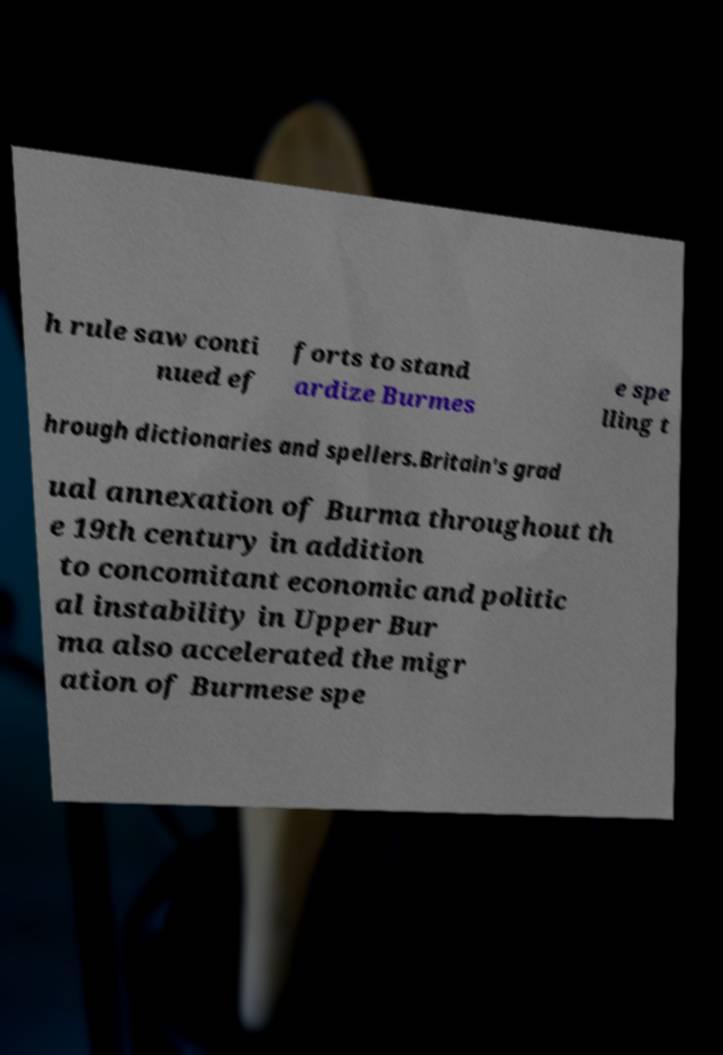What messages or text are displayed in this image? I need them in a readable, typed format. h rule saw conti nued ef forts to stand ardize Burmes e spe lling t hrough dictionaries and spellers.Britain's grad ual annexation of Burma throughout th e 19th century in addition to concomitant economic and politic al instability in Upper Bur ma also accelerated the migr ation of Burmese spe 